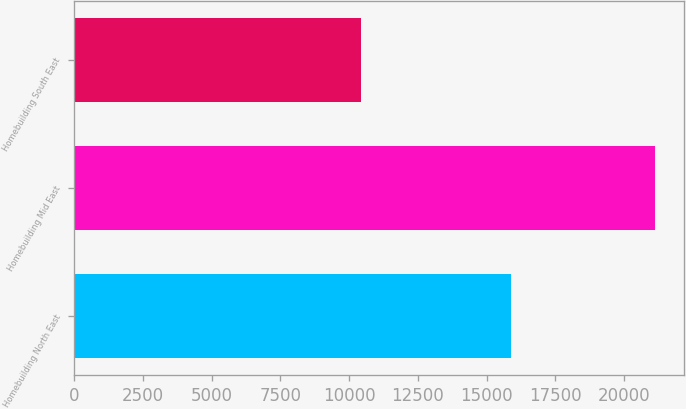<chart> <loc_0><loc_0><loc_500><loc_500><bar_chart><fcel>Homebuilding North East<fcel>Homebuilding Mid East<fcel>Homebuilding South East<nl><fcel>15904<fcel>21126<fcel>10423<nl></chart> 